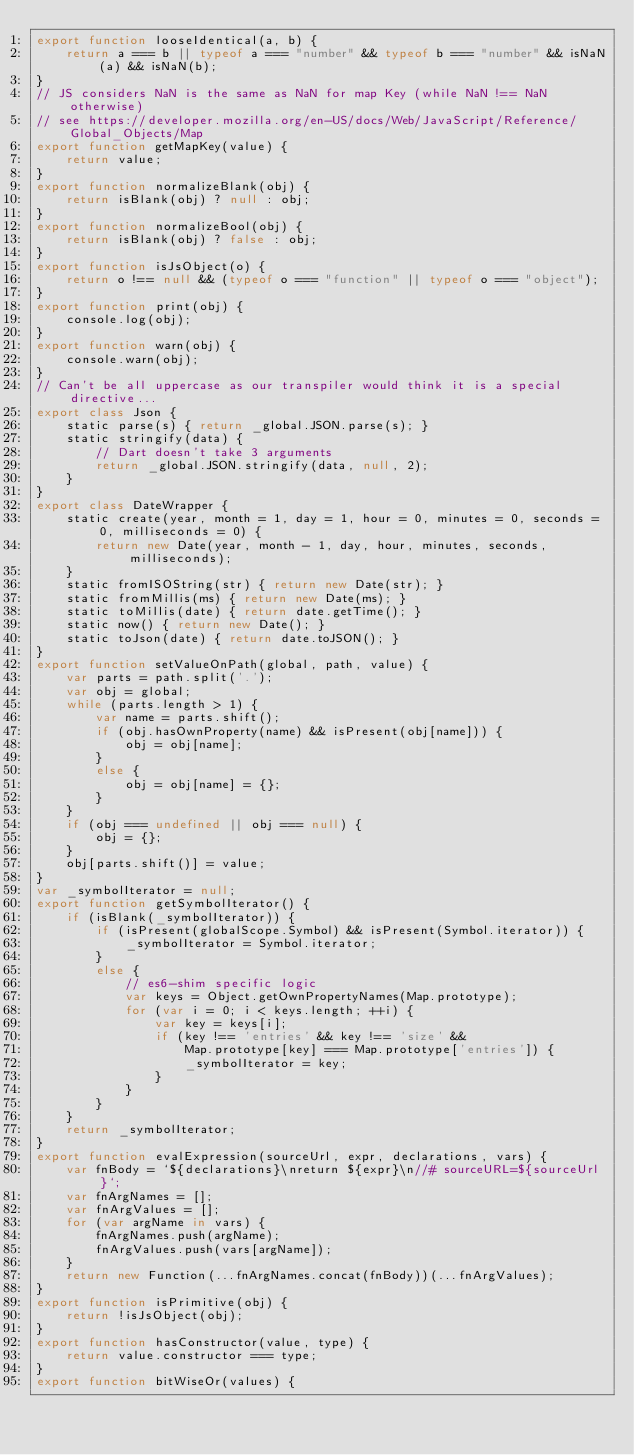Convert code to text. <code><loc_0><loc_0><loc_500><loc_500><_JavaScript_>export function looseIdentical(a, b) {
    return a === b || typeof a === "number" && typeof b === "number" && isNaN(a) && isNaN(b);
}
// JS considers NaN is the same as NaN for map Key (while NaN !== NaN otherwise)
// see https://developer.mozilla.org/en-US/docs/Web/JavaScript/Reference/Global_Objects/Map
export function getMapKey(value) {
    return value;
}
export function normalizeBlank(obj) {
    return isBlank(obj) ? null : obj;
}
export function normalizeBool(obj) {
    return isBlank(obj) ? false : obj;
}
export function isJsObject(o) {
    return o !== null && (typeof o === "function" || typeof o === "object");
}
export function print(obj) {
    console.log(obj);
}
export function warn(obj) {
    console.warn(obj);
}
// Can't be all uppercase as our transpiler would think it is a special directive...
export class Json {
    static parse(s) { return _global.JSON.parse(s); }
    static stringify(data) {
        // Dart doesn't take 3 arguments
        return _global.JSON.stringify(data, null, 2);
    }
}
export class DateWrapper {
    static create(year, month = 1, day = 1, hour = 0, minutes = 0, seconds = 0, milliseconds = 0) {
        return new Date(year, month - 1, day, hour, minutes, seconds, milliseconds);
    }
    static fromISOString(str) { return new Date(str); }
    static fromMillis(ms) { return new Date(ms); }
    static toMillis(date) { return date.getTime(); }
    static now() { return new Date(); }
    static toJson(date) { return date.toJSON(); }
}
export function setValueOnPath(global, path, value) {
    var parts = path.split('.');
    var obj = global;
    while (parts.length > 1) {
        var name = parts.shift();
        if (obj.hasOwnProperty(name) && isPresent(obj[name])) {
            obj = obj[name];
        }
        else {
            obj = obj[name] = {};
        }
    }
    if (obj === undefined || obj === null) {
        obj = {};
    }
    obj[parts.shift()] = value;
}
var _symbolIterator = null;
export function getSymbolIterator() {
    if (isBlank(_symbolIterator)) {
        if (isPresent(globalScope.Symbol) && isPresent(Symbol.iterator)) {
            _symbolIterator = Symbol.iterator;
        }
        else {
            // es6-shim specific logic
            var keys = Object.getOwnPropertyNames(Map.prototype);
            for (var i = 0; i < keys.length; ++i) {
                var key = keys[i];
                if (key !== 'entries' && key !== 'size' &&
                    Map.prototype[key] === Map.prototype['entries']) {
                    _symbolIterator = key;
                }
            }
        }
    }
    return _symbolIterator;
}
export function evalExpression(sourceUrl, expr, declarations, vars) {
    var fnBody = `${declarations}\nreturn ${expr}\n//# sourceURL=${sourceUrl}`;
    var fnArgNames = [];
    var fnArgValues = [];
    for (var argName in vars) {
        fnArgNames.push(argName);
        fnArgValues.push(vars[argName]);
    }
    return new Function(...fnArgNames.concat(fnBody))(...fnArgValues);
}
export function isPrimitive(obj) {
    return !isJsObject(obj);
}
export function hasConstructor(value, type) {
    return value.constructor === type;
}
export function bitWiseOr(values) {</code> 